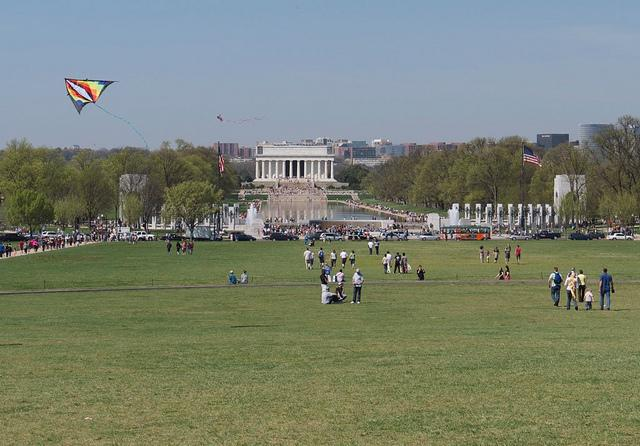In which country is this park located? united states 